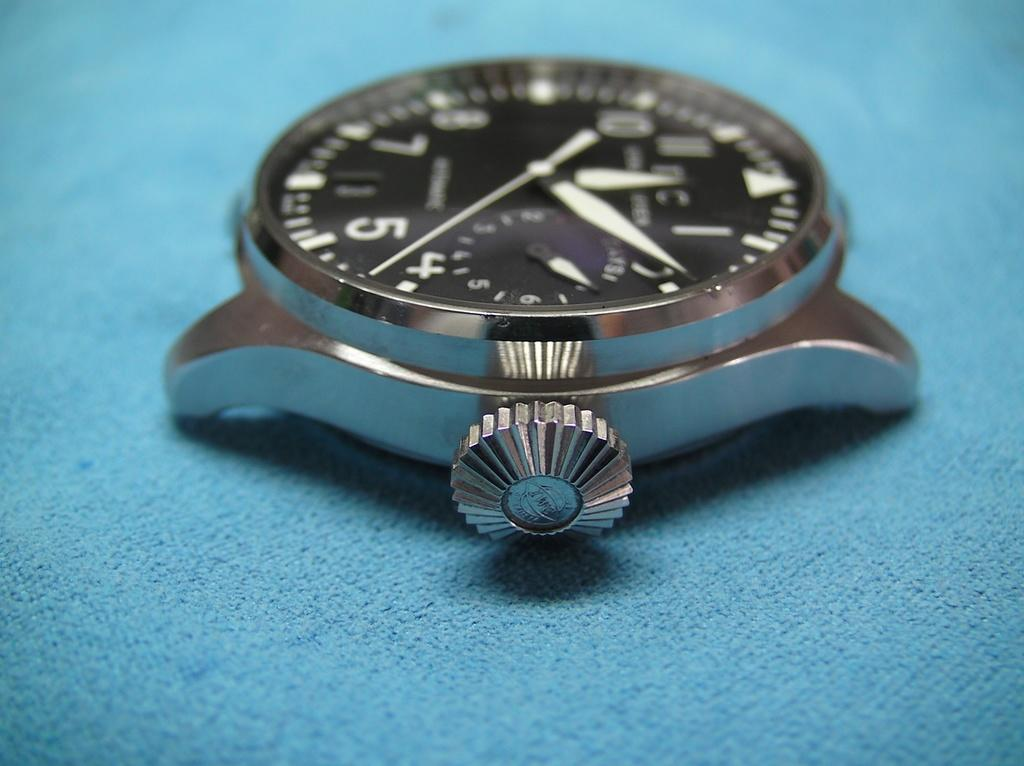Provide a one-sentence caption for the provided image. A watch face sits on a blue surface, and it is approximately 12:09. 